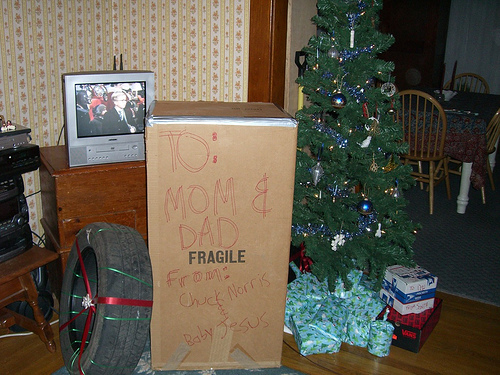<image>
Is the tire on the box? Yes. Looking at the image, I can see the tire is positioned on top of the box, with the box providing support. Where is the box in relation to the television? Is it next to the television? Yes. The box is positioned adjacent to the television, located nearby in the same general area. Is there a tv next to the tree? Yes. The tv is positioned adjacent to the tree, located nearby in the same general area. 